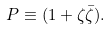<formula> <loc_0><loc_0><loc_500><loc_500>P \equiv ( 1 + \zeta \bar { \zeta } ) .</formula> 